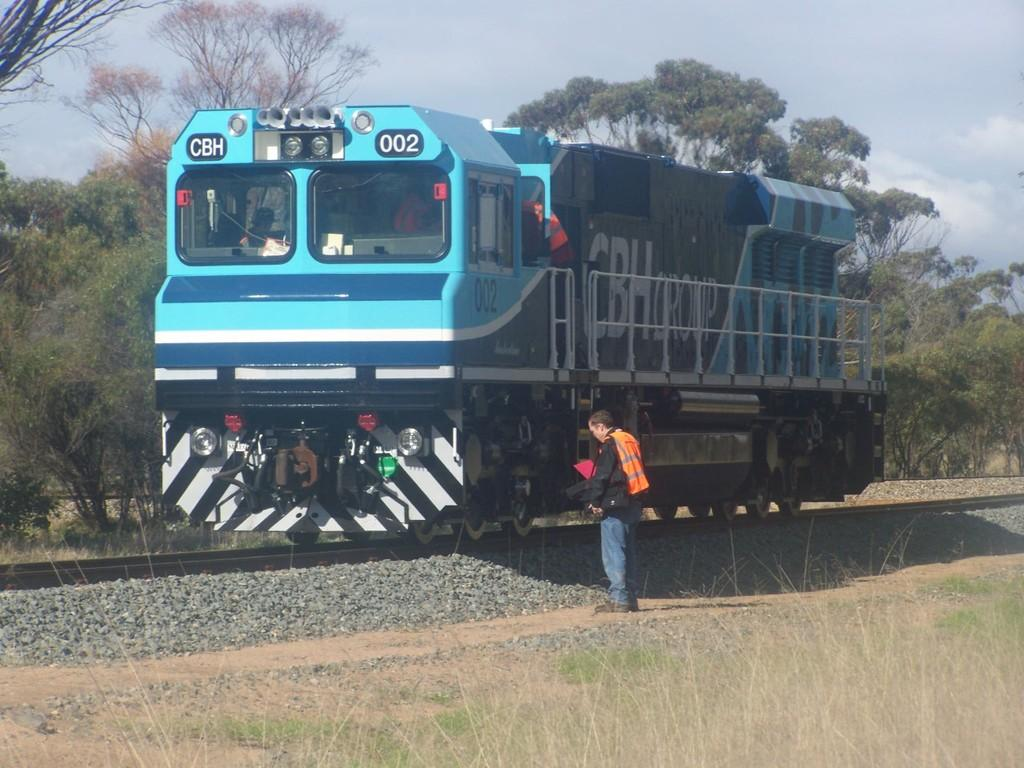What is the main subject of the image? The main subject of the image is a train. What is the train doing in the image? The train is standing still in the image. Is there anyone near the train in the image? Yes, there is a man standing near the train. What type of cloth is the dad wearing in the image? There is no dad or cloth present in the image; it only features a train and a man standing near it. 